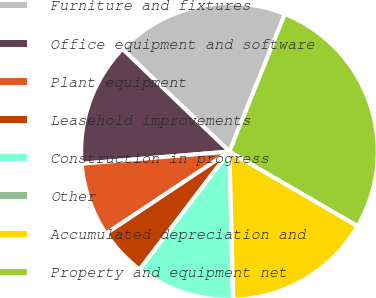Convert chart to OTSL. <chart><loc_0><loc_0><loc_500><loc_500><pie_chart><fcel>Furniture and fixtures<fcel>Office equipment and software<fcel>Plant equipment<fcel>Leasehold improvements<fcel>Construction in progress<fcel>Other<fcel>Accumulated depreciation and<fcel>Property and equipment net<nl><fcel>18.93%<fcel>13.48%<fcel>8.03%<fcel>5.3%<fcel>10.75%<fcel>0.03%<fcel>16.2%<fcel>27.28%<nl></chart> 